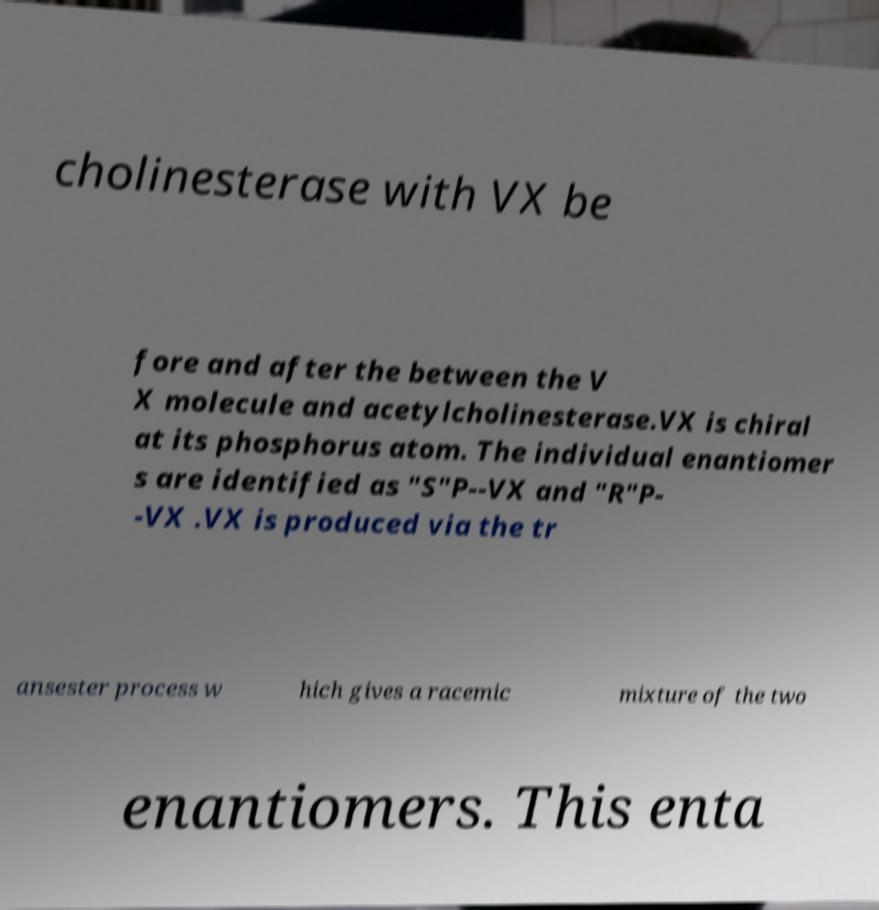For documentation purposes, I need the text within this image transcribed. Could you provide that? cholinesterase with VX be fore and after the between the V X molecule and acetylcholinesterase.VX is chiral at its phosphorus atom. The individual enantiomer s are identified as "S"P--VX and "R"P- -VX .VX is produced via the tr ansester process w hich gives a racemic mixture of the two enantiomers. This enta 